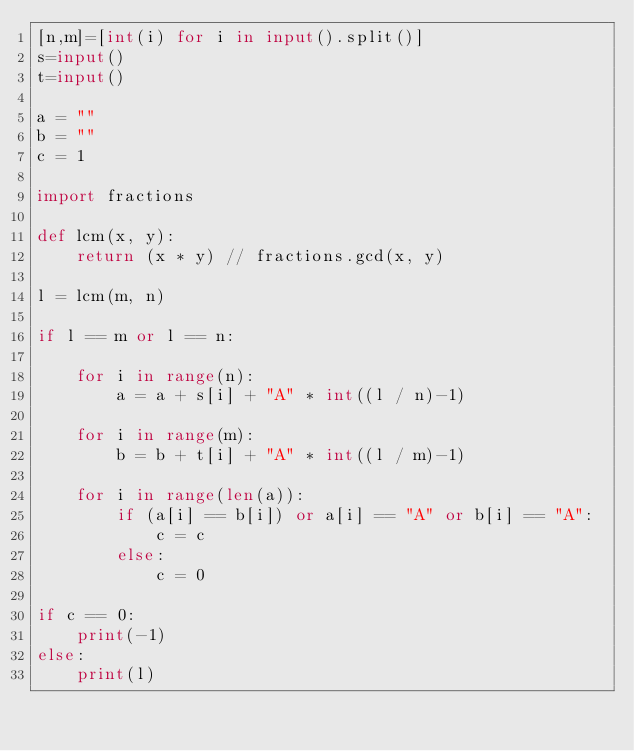<code> <loc_0><loc_0><loc_500><loc_500><_Python_>[n,m]=[int(i) for i in input().split()]
s=input()
t=input()

a = ""
b = ""
c = 1

import fractions

def lcm(x, y):
    return (x * y) // fractions.gcd(x, y)

l = lcm(m, n)

if l == m or l == n:

    for i in range(n):
        a = a + s[i] + "A" * int((l / n)-1)

    for i in range(m):
        b = b + t[i] + "A" * int((l / m)-1)

    for i in range(len(a)):
        if (a[i] == b[i]) or a[i] == "A" or b[i] == "A":
            c = c
        else:
            c = 0

if c == 0:
    print(-1)
else:
    print(l)
</code> 